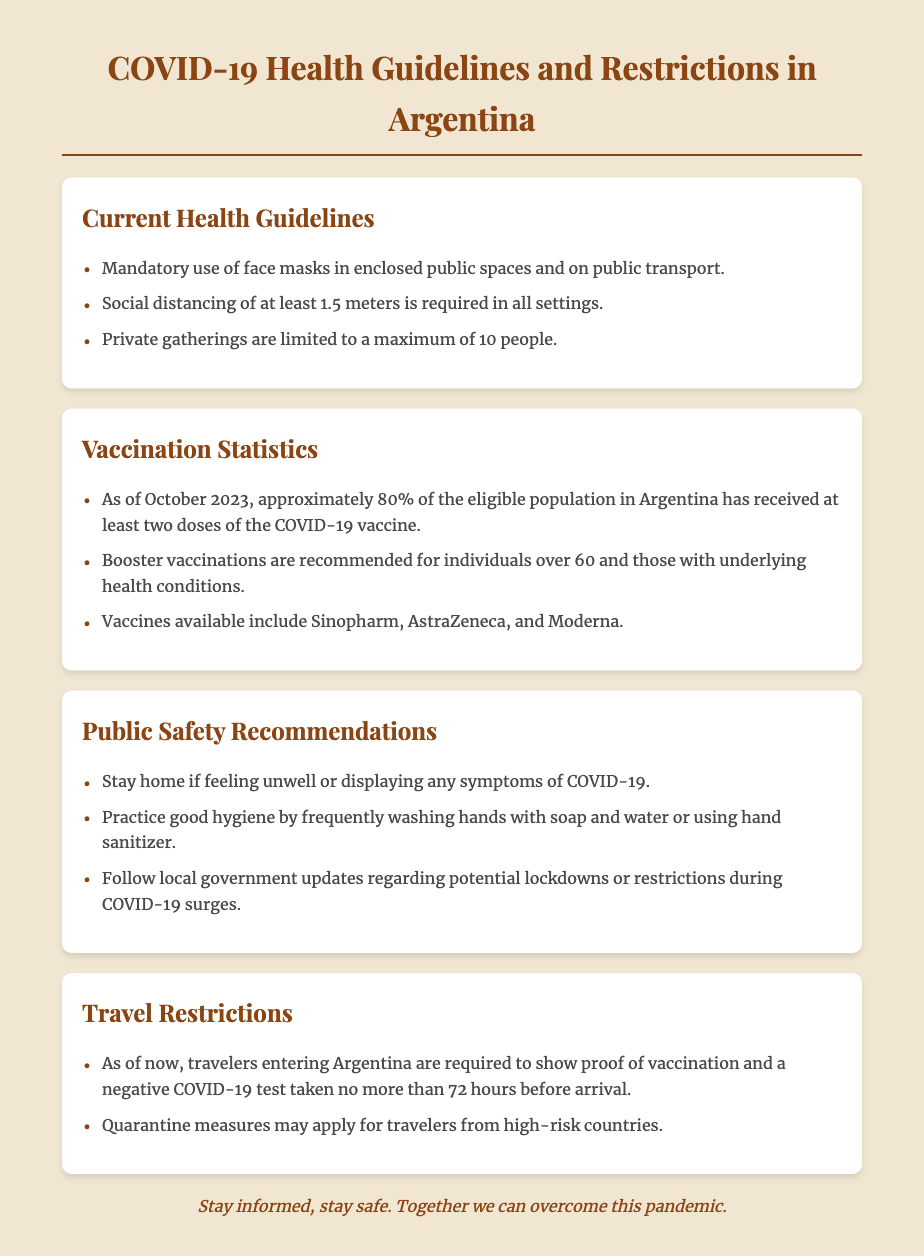what is the maximum number of people allowed at private gatherings? The document states the limit for private gatherings is a maximum of 10 people.
Answer: 10 people what percentage of the eligible population has received at least two doses of the vaccine? The document mentions that approximately 80% of the eligible population has received at least two doses of the COVID-19 vaccine.
Answer: 80% which vaccines are available in Argentina? The document lists Sinopharm, AstraZeneca, and Moderna as available vaccines.
Answer: Sinopharm, AstraZeneca, Moderna what is the required distance for social distancing? The document specifies that social distancing of at least 1.5 meters is required.
Answer: 1.5 meters what should travelers show when entering Argentina? According to the document, travelers are required to show proof of vaccination and a negative COVID-19 test.
Answer: Proof of vaccination and a negative COVID-19 test who is recommended to receive booster vaccinations? The document states that booster vaccinations are recommended for individuals over 60 and those with underlying health conditions.
Answer: Individuals over 60 and those with underlying health conditions what is one recommendation for public safety? The document suggests staying home if feeling unwell or displaying any symptoms of COVID-19.
Answer: Stay home if feeling unwell what is the main theme of this document? The document discusses health guidelines and restrictions during the COVID-19 pandemic in Argentina.
Answer: Health guidelines and restrictions during the COVID-19 pandemic how is the layout of the document organized? The document is organized into sections such as Current Health Guidelines, Vaccination Statistics, Public Safety Recommendations, and Travel Restrictions.
Answer: Sections like Current Health Guidelines, Vaccination Statistics, Public Safety Recommendations, and Travel Restrictions 